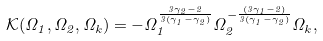<formula> <loc_0><loc_0><loc_500><loc_500>\mathcal { K } ( \Omega _ { 1 } , \Omega _ { 2 } , \Omega _ { k } ) = - \Omega _ { 1 } ^ { \frac { 3 \gamma _ { 2 } - 2 } { 3 ( \gamma _ { 1 } - \gamma _ { 2 } ) } } \Omega _ { 2 } ^ { - \frac { ( 3 \gamma _ { 1 } - 2 ) } { 3 ( \gamma _ { 1 } - \gamma _ { 2 } ) } } \Omega _ { k } ,</formula> 